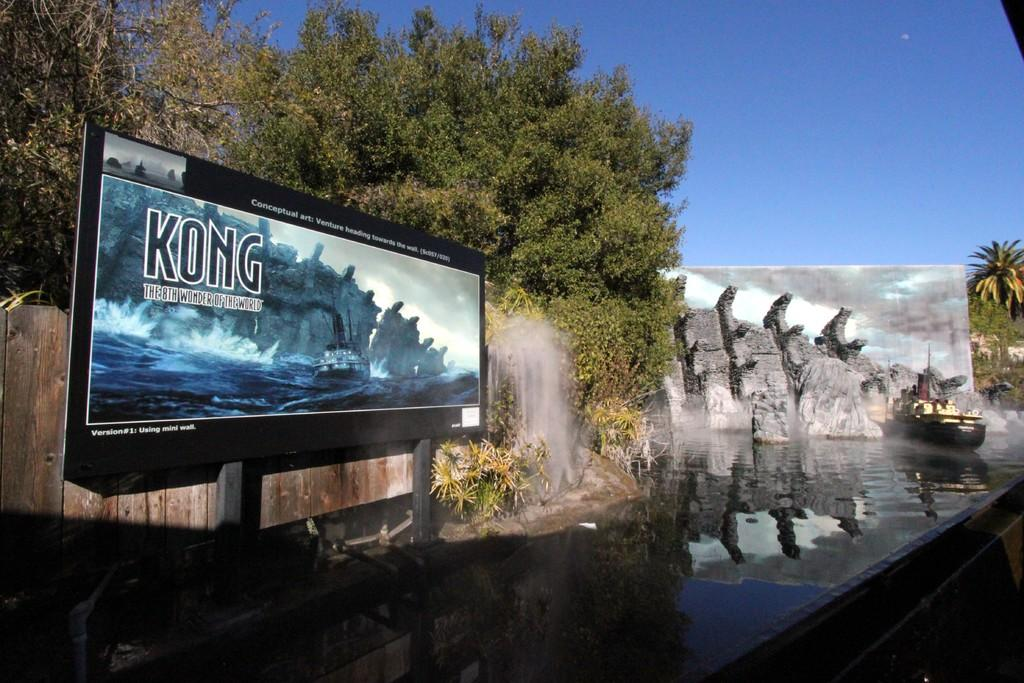Provide a one-sentence caption for the provided image. A billboard advertisement for the water ride Kong. 